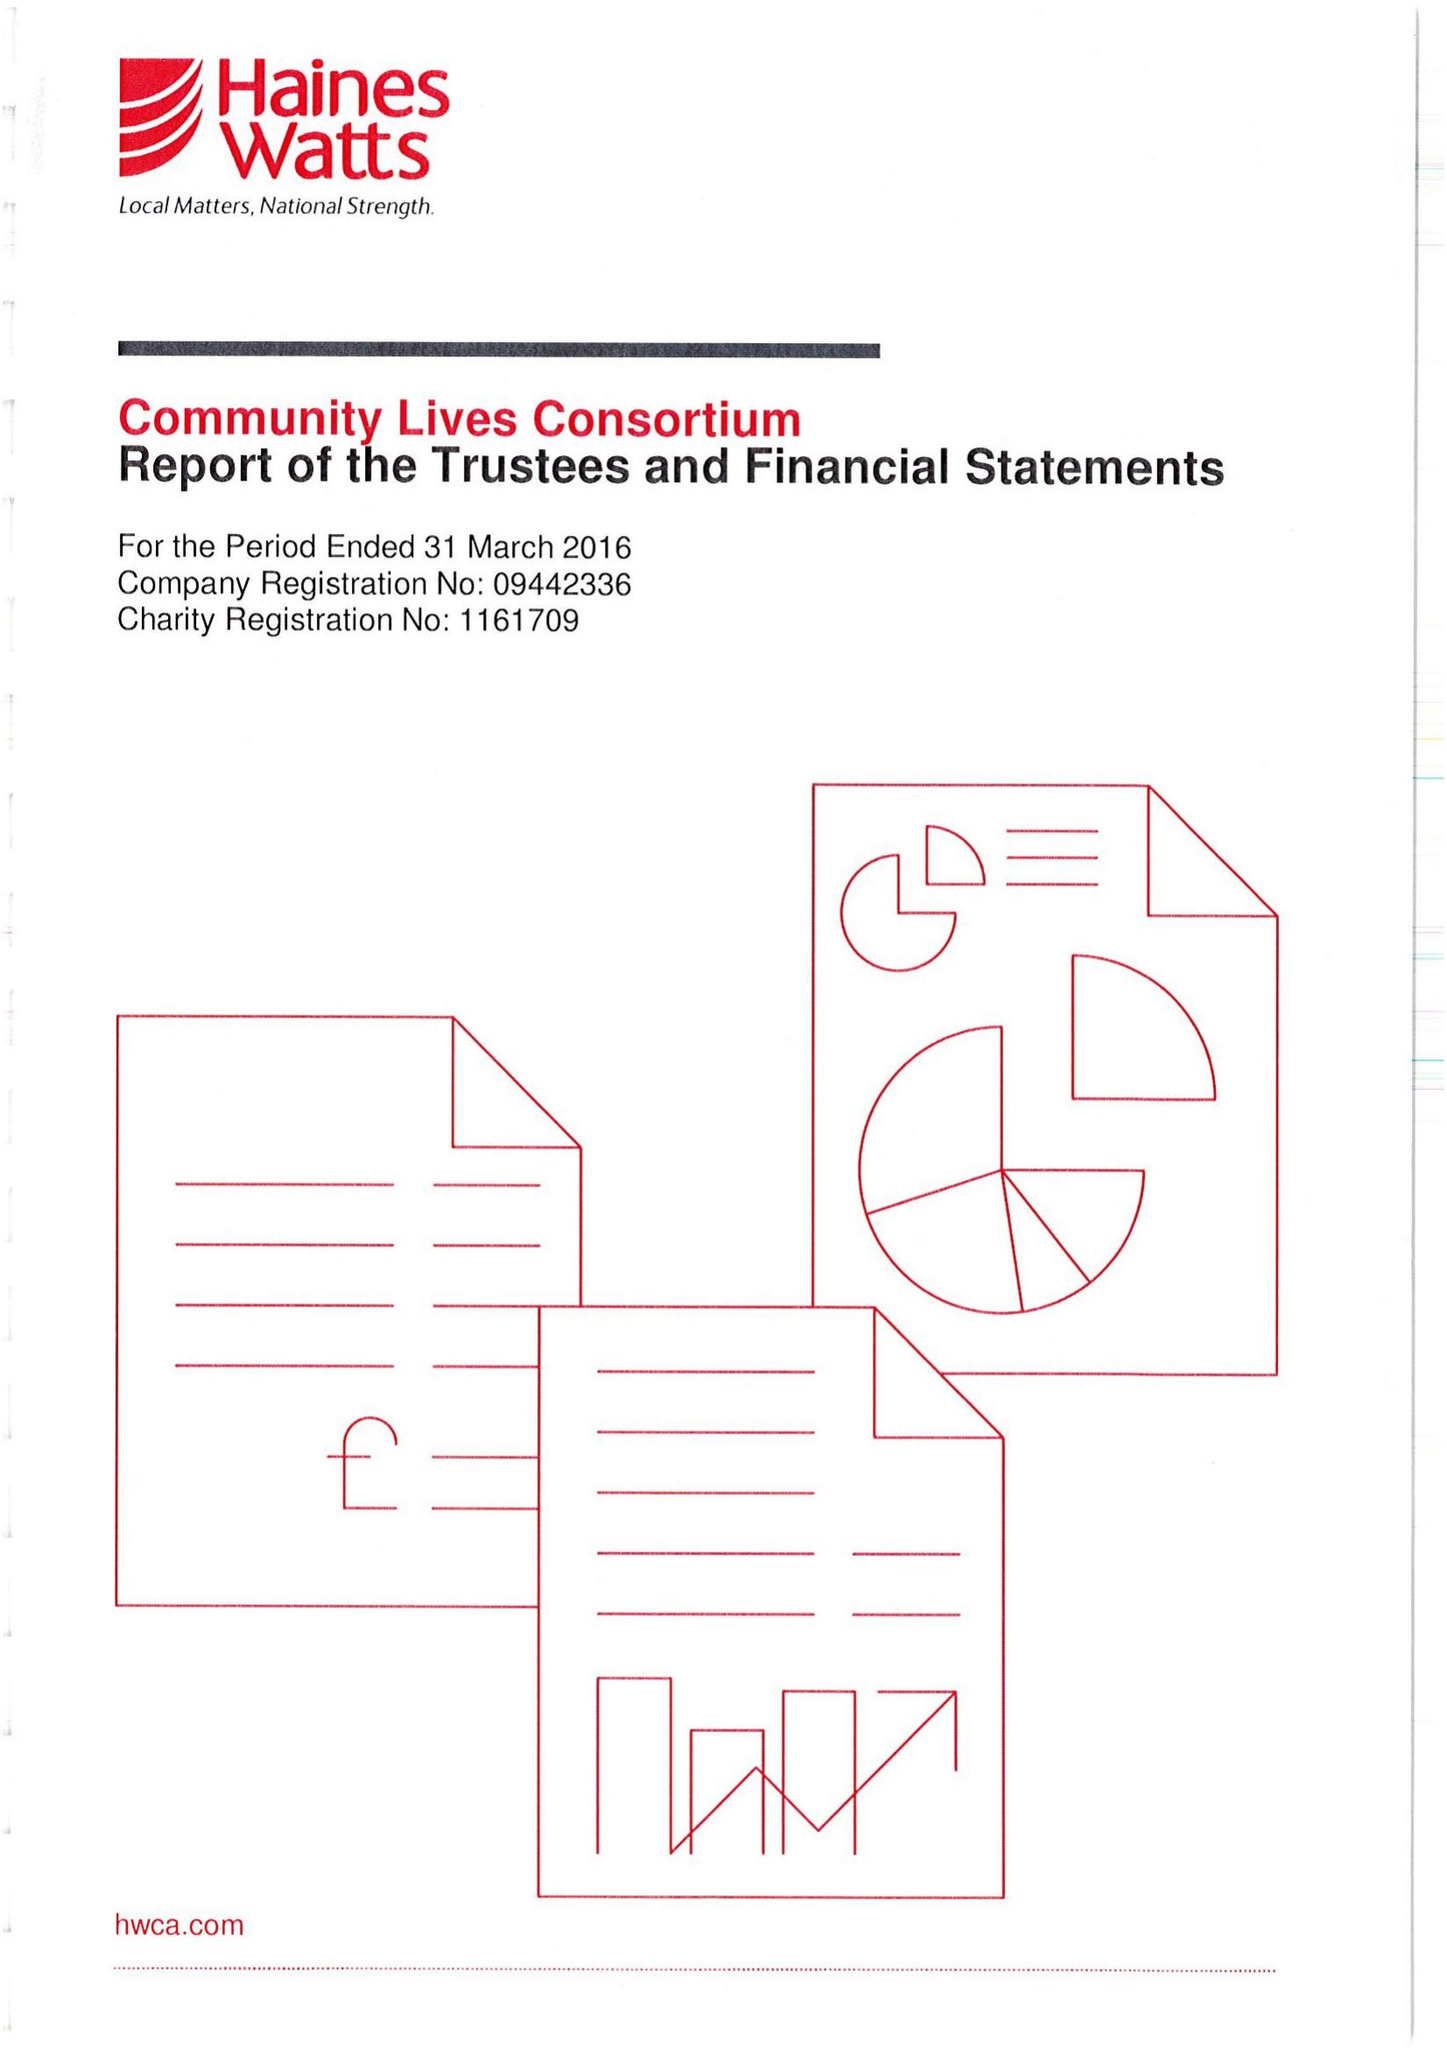What is the value for the address__post_town?
Answer the question using a single word or phrase. SWANSEA 